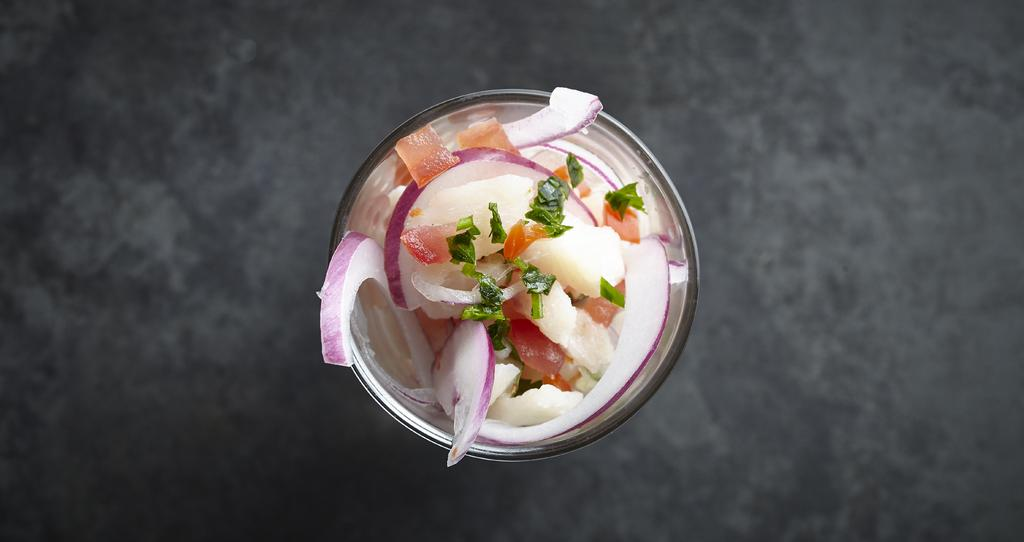What is located on the floor in the image? There is a bowl on the floor in the image. What type of food is in the bowl? There are vegetables in the bowl, including sliced onions, chopped tomatoes, herbs, and potatoes. Can you describe the vegetables in the bowl? The bowl contains sliced onions, chopped tomatoes, herbs, and potatoes. What color is the rose in the vest in the image? There is no rose or vest present in the image; it only features a bowl with vegetables on the floor. 